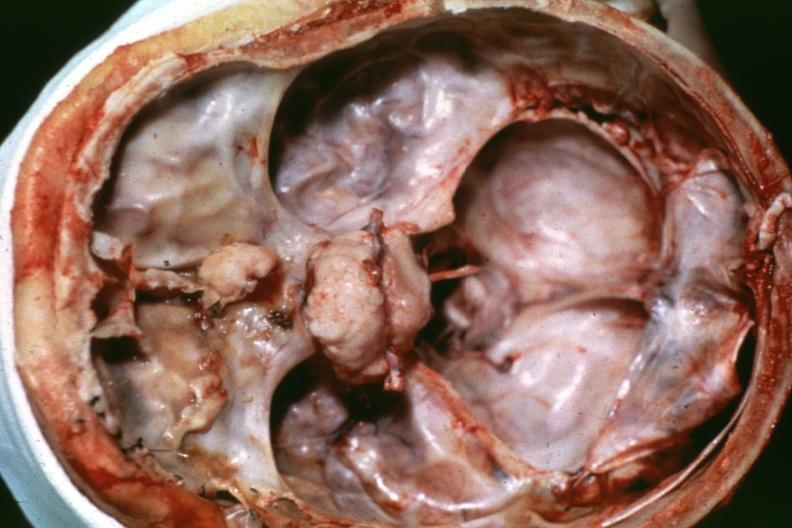what is present?
Answer the question using a single word or phrase. Meningioma 